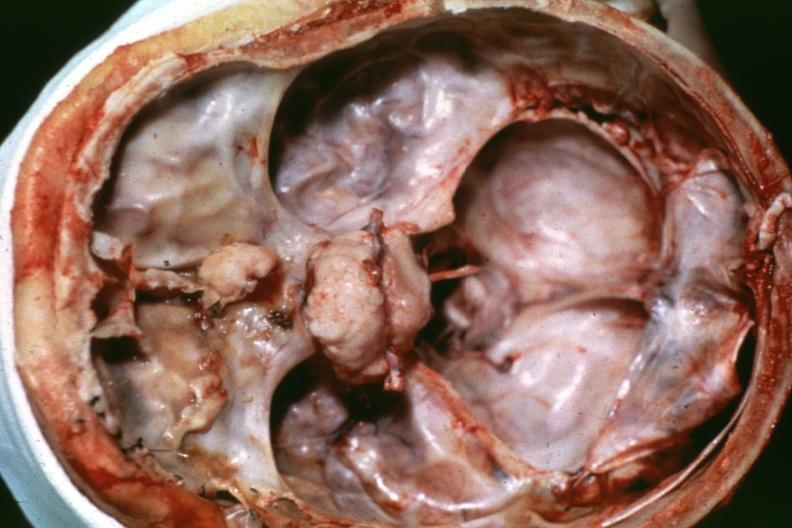what is present?
Answer the question using a single word or phrase. Meningioma 